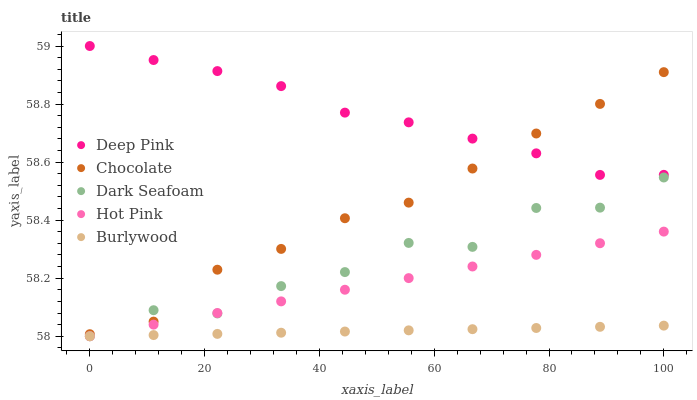Does Burlywood have the minimum area under the curve?
Answer yes or no. Yes. Does Deep Pink have the maximum area under the curve?
Answer yes or no. Yes. Does Dark Seafoam have the minimum area under the curve?
Answer yes or no. No. Does Dark Seafoam have the maximum area under the curve?
Answer yes or no. No. Is Burlywood the smoothest?
Answer yes or no. Yes. Is Dark Seafoam the roughest?
Answer yes or no. Yes. Is Deep Pink the smoothest?
Answer yes or no. No. Is Deep Pink the roughest?
Answer yes or no. No. Does Burlywood have the lowest value?
Answer yes or no. Yes. Does Deep Pink have the lowest value?
Answer yes or no. No. Does Deep Pink have the highest value?
Answer yes or no. Yes. Does Dark Seafoam have the highest value?
Answer yes or no. No. Is Burlywood less than Deep Pink?
Answer yes or no. Yes. Is Deep Pink greater than Hot Pink?
Answer yes or no. Yes. Does Hot Pink intersect Dark Seafoam?
Answer yes or no. Yes. Is Hot Pink less than Dark Seafoam?
Answer yes or no. No. Is Hot Pink greater than Dark Seafoam?
Answer yes or no. No. Does Burlywood intersect Deep Pink?
Answer yes or no. No. 